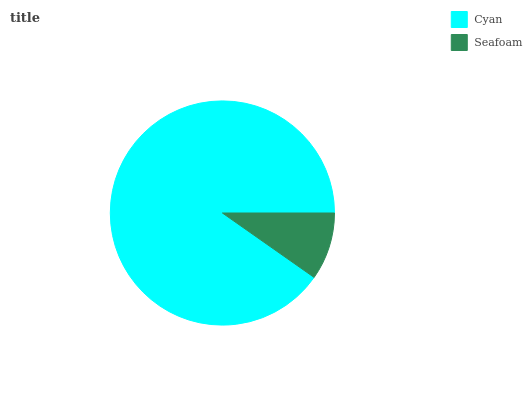Is Seafoam the minimum?
Answer yes or no. Yes. Is Cyan the maximum?
Answer yes or no. Yes. Is Seafoam the maximum?
Answer yes or no. No. Is Cyan greater than Seafoam?
Answer yes or no. Yes. Is Seafoam less than Cyan?
Answer yes or no. Yes. Is Seafoam greater than Cyan?
Answer yes or no. No. Is Cyan less than Seafoam?
Answer yes or no. No. Is Cyan the high median?
Answer yes or no. Yes. Is Seafoam the low median?
Answer yes or no. Yes. Is Seafoam the high median?
Answer yes or no. No. Is Cyan the low median?
Answer yes or no. No. 